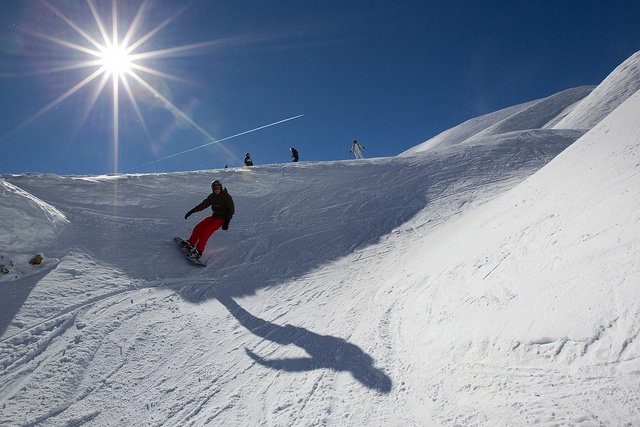Describe the objects in this image and their specific colors. I can see people in blue, black, maroon, and gray tones, snowboard in blue, black, and gray tones, people in blue, gray, and black tones, people in blue, black, gray, and navy tones, and people in blue, black, and navy tones in this image. 